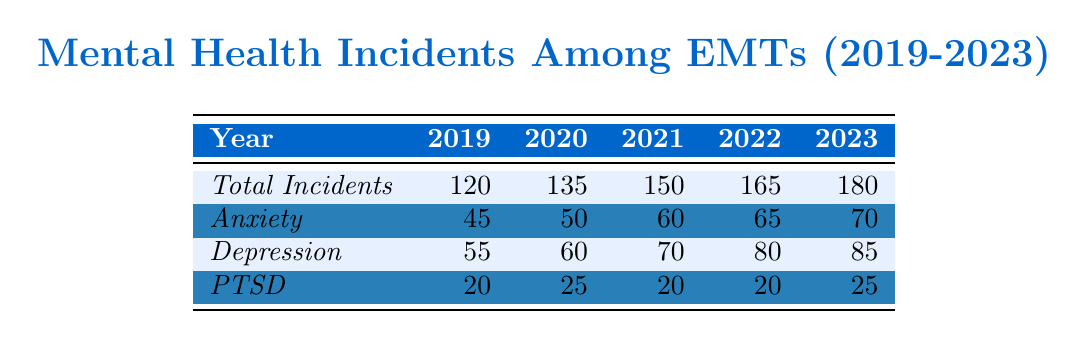What was the total number of mental health incidents reported among EMTs in 2021? According to the table, the total number of mental health incidents reported in 2021 is specifically listed under the "Total Incidents" row for that year. Looking at the table, it shows 150 incidents in 2021.
Answer: 150 In which year were the highest number of anxiety incidents reported? From the table, we see the numbers for anxiety incidents across the years: 45 in 2019, 50 in 2020, 60 in 2021, 65 in 2022, and 70 in 2023. The year 2023 has the highest count of 70.
Answer: 2023 What is the percentage increase in total incidents from 2019 to 2023? To calculate the percentage increase, use the formula: ((New Value - Old Value) / Old Value) * 100. Here, New Value is 180 (2023) and Old Value is 120 (2019). Thus: ((180 - 120) / 120) * 100 = 50%.
Answer: 50% How many more depression incidents were reported in 2023 compared to 2019? The table lists depression incidents as 55 in 2019 and 85 in 2023. The difference is calculated by subtracting the 2019 incidents from those in 2023: 85 - 55 = 30.
Answer: 30 Is the total number of PTSD incidents in 2022 greater than in 2020? In 2022, the table shows 20 PTSD incidents, and in 2020, it shows 25. Comparing these two, 20 is not greater than 25, so the statement is false.
Answer: No What was the average number of anxiety incidents reported over the five years? The anxiety incidents reported over the five years are: 45, 50, 60, 65, and 70. Summing these values gives 290. To find the average, divide by the number of years: 290 / 5 = 58.
Answer: 58 In which year did the number of total incidents first exceed 150? By observing the total incidents for each year, we find that 150 incidents occurred in 2021, and the subsequent year, 2022, shows 165. Therefore, 2021 is the first year that reached or exceeded 150 incidents.
Answer: 2021 What is the total number of mental health incidents reported from 2019 to 2023? To find the total, add the total incidents from each year: 120 (2019) + 135 (2020) + 150 (2021) + 165 (2022) + 180 (2023) = 850.
Answer: 850 How many more anxiety incidents were reported in 2022 than in 2021? The table indicates that there were 65 anxiety incidents in 2022 and 60 in 2021. The difference is calculated by subtracting the 2021 incidents from 2022 incidents: 65 - 60 = 5.
Answer: 5 Which mental health issue had the highest total incidents over the five years? By summing the incidents across all years: Anxiety (45+50+60+65+70=290), Depression (55+60+70+80+85=350), PTSD (20+25+20+20+25=110). Comparing these totals, Depression had the highest count of 350.
Answer: Depression 